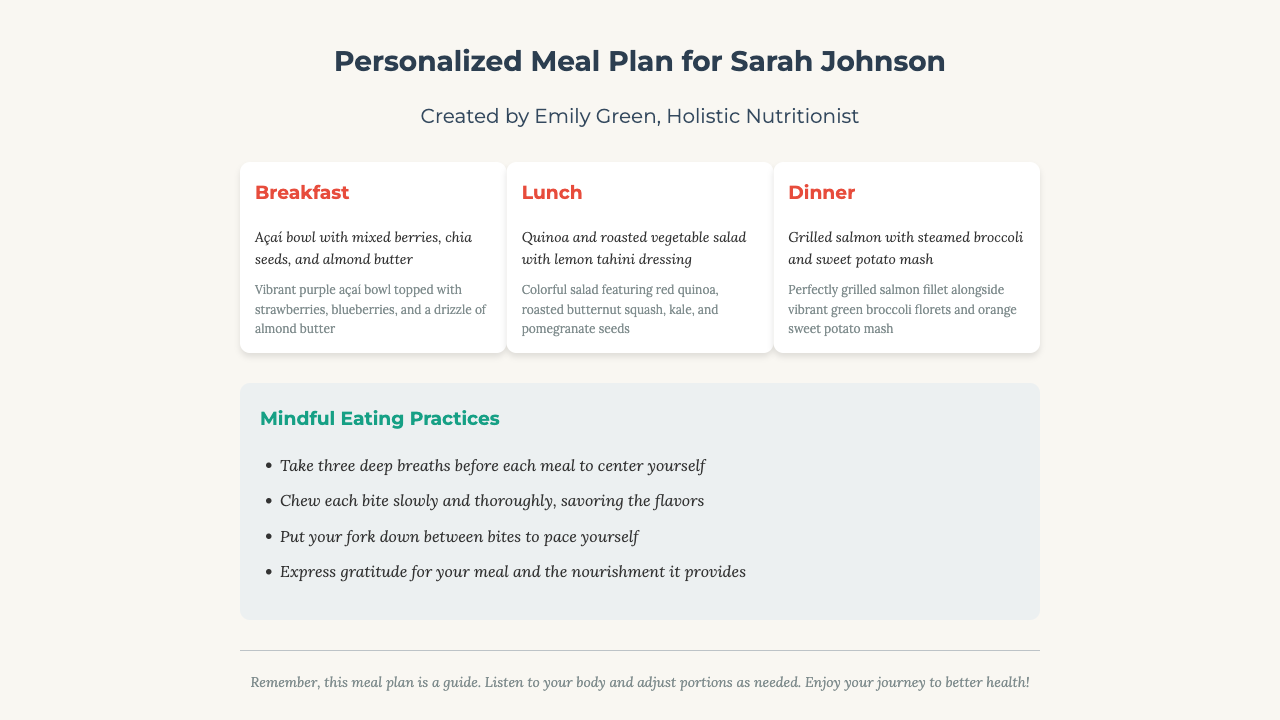What is the client's name? The client's name is mentioned in the title of the document.
Answer: Sarah Johnson Who created the meal plan? The creator of the meal plan is specified under the header section.
Answer: Emily Green What is the primary ingredient in the breakfast meal? The breakfast description includes a prominent ingredient.
Answer: Açaí What type of salad is featured in the lunch meal? The lunch meal description specifies the type of salad.
Answer: Quinoa and roasted vegetable salad What is one practice listed under Mindful Eating Practices? The document lists multiple mindful eating practices, highlighting the importance of taking time during meals.
Answer: Take three deep breaths before each meal to center yourself How many meals are outlined in this plan? The document outlines three distinct meals as part of the personalized plan.
Answer: Three What color is the sweet potato mash served with dinner? The dinner description mentions the specific color of the sweet potato mash.
Answer: Orange What should you do between bites according to the mindful eating practices? The mindful eating section discusses pacing yourself during meals.
Answer: Put your fork down What is the background color of the document? The visual style of the document specifies a background color that sets the mood of the layout.
Answer: #f9f7f2 